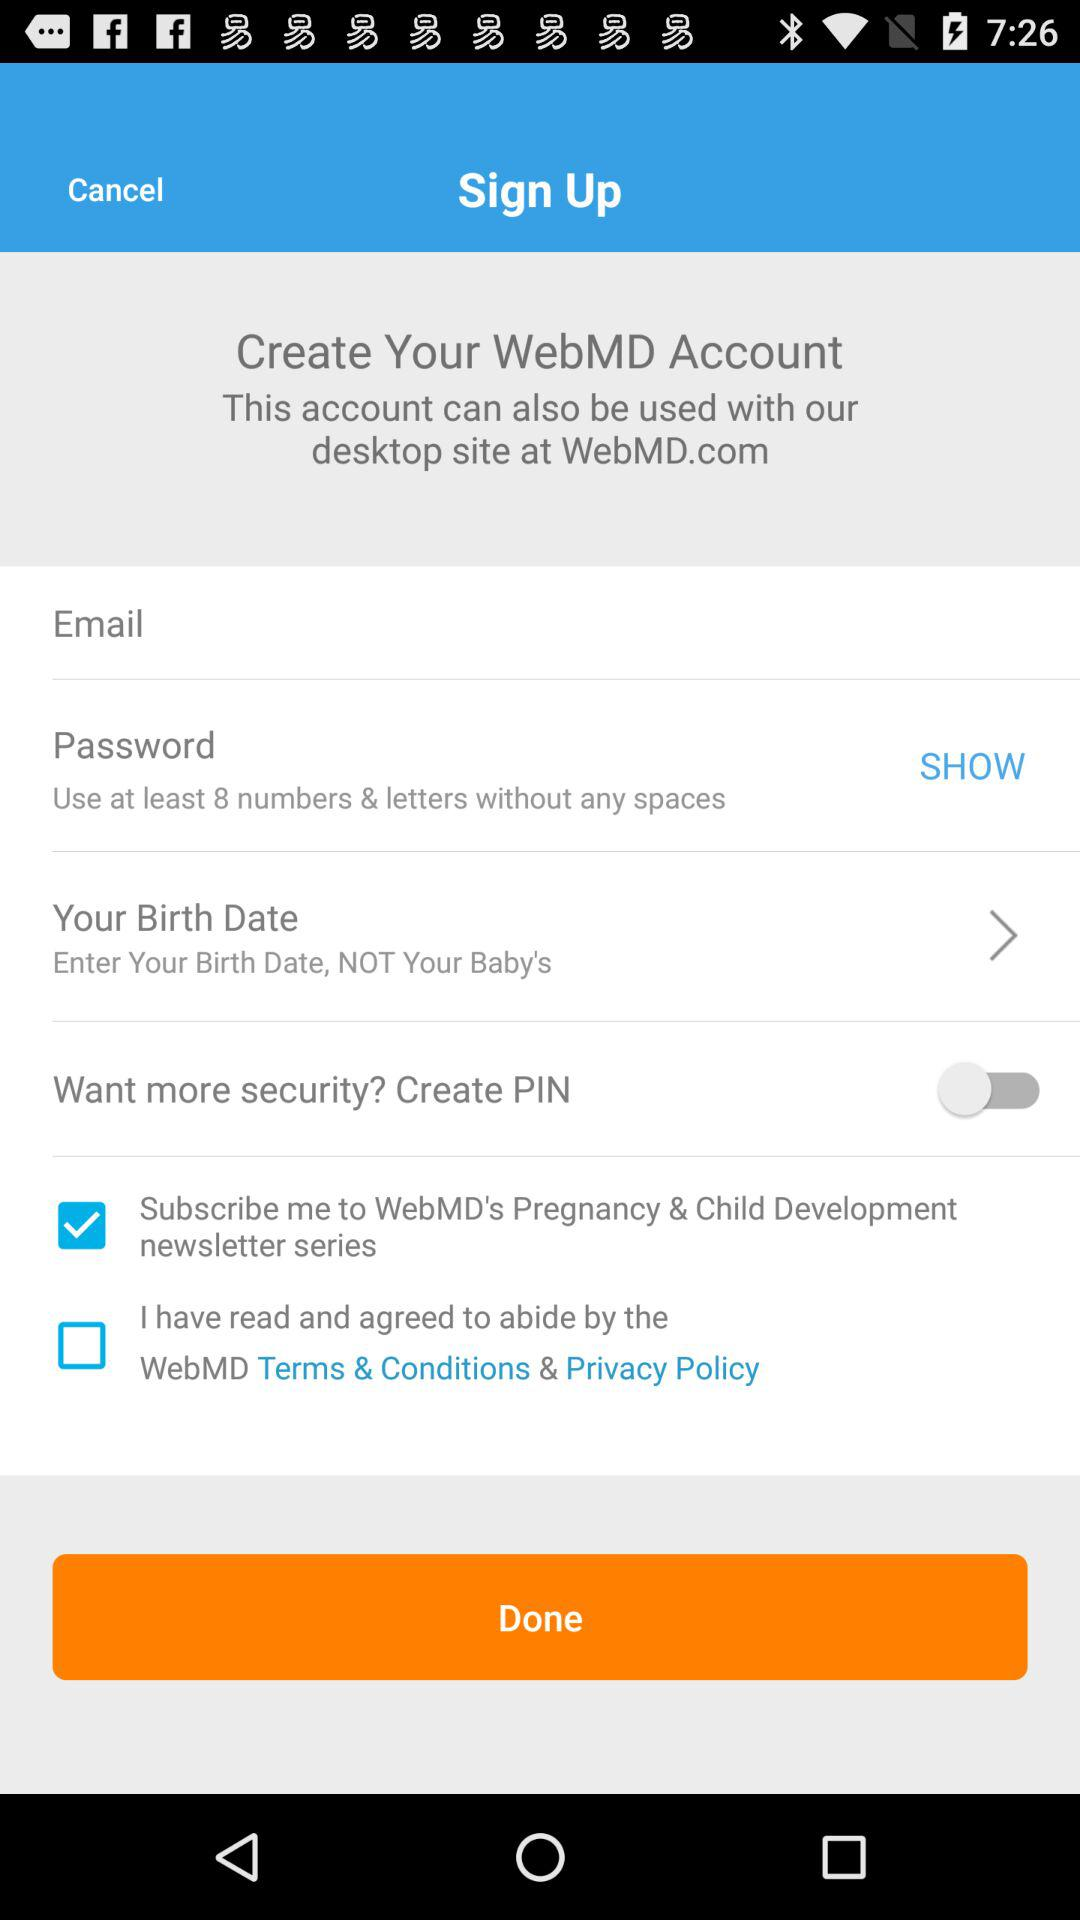What is the status of the Create PIN? The status of the Create PIN is off. 